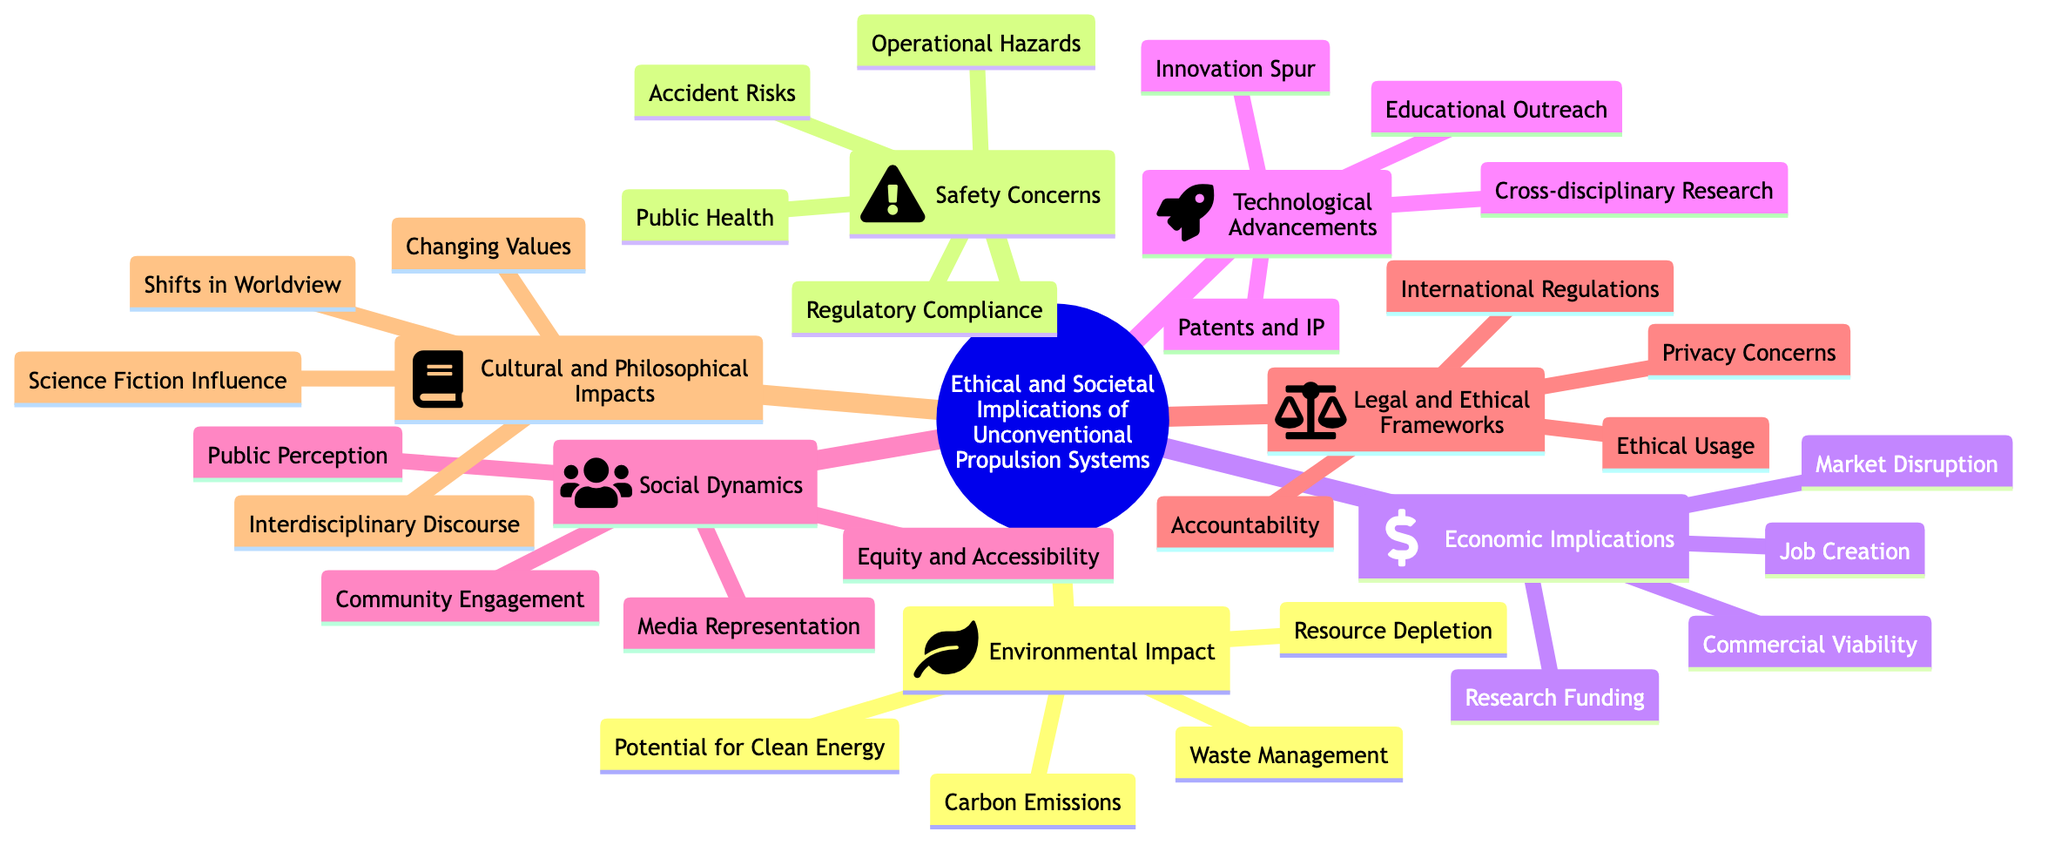What is the main topic of the mind map? The central theme of the diagram is clearly identified as "Ethical and Societal Implications of Unconventional Propulsion Systems," which is displayed as the overarching node.
Answer: Ethical and Societal Implications of Unconventional Propulsion Systems How many subtopics are presented in the diagram? By counting the subtopics listed under the main topic, we find there are seven distinct categories, including Environmental Impact, Safety Concerns, Economic Implications, Technological Advancements, Social Dynamics, Legal and Ethical Frameworks, and Cultural and Philosophical Impacts.
Answer: 7 What is a key element under the subtopic 'Safety Concerns'? Looking under the 'Safety Concerns' section, 'Accident Risks' is one of the specific elements listed, highlighting one of the main areas of concern related to safety.
Answer: Accident Risks Which subtopic has the most elements listed? Upon reviewing the diagram, we find that 'Environmental Impact' contains four elements: Carbon Emissions, Resource Depletion, Waste Management, and Potential for Clean Energy, which is the highest compared to other subtopics.
Answer: Environmental Impact What is a potential positive aspect of unconventional propulsion systems mentioned in the diagram? The element 'Potential for Clean Energy' under the 'Environmental Impact' subtopic points toward a hopeful outcome related to unconventional propulsion systems.
Answer: Potential for Clean Energy Which subtopic includes topics related to public engagement? The 'Social Dynamics' subtopic includes elements that focus on the interaction and perception of the public, such as Public Perception and Community Engagement, indicating concern for societal relations.
Answer: Social Dynamics How are technological advancements likely to influence research? The 'Technological Advancements' subtopic includes 'Cross-disciplinary Research' as an element, suggesting a positive impact on the collaborative nature of scientific exploration regarding unconventional propulsion systems.
Answer: Cross-disciplinary Research Identify one aspect related to the ethical usage in the legal framework discussed. Within 'Legal and Ethical Frameworks', one pertinent topic is 'Ethical Usage', which explicitly deals with the moral implications surrounding the application of unconventional propulsion technologies.
Answer: Ethical Usage What is a potential cultural impact noted in the mind map? In the 'Cultural and Philosophical Impacts' section, 'Science Fiction Influence' is mentioned, indicating how fictional narratives might shape public perception and acceptance of unconventional propulsion systems.
Answer: Science Fiction Influence 